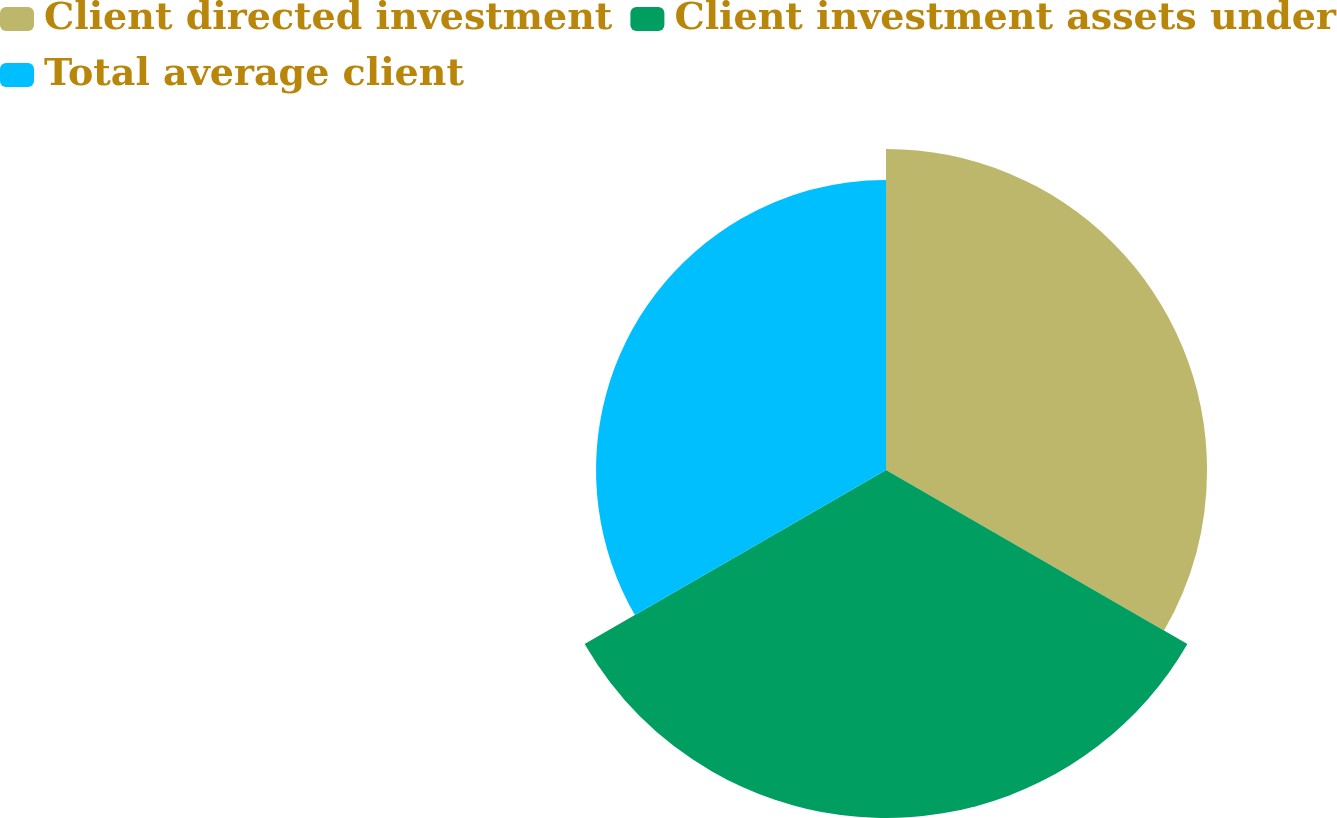Convert chart. <chart><loc_0><loc_0><loc_500><loc_500><pie_chart><fcel>Client directed investment<fcel>Client investment assets under<fcel>Total average client<nl><fcel>33.48%<fcel>36.29%<fcel>30.24%<nl></chart> 